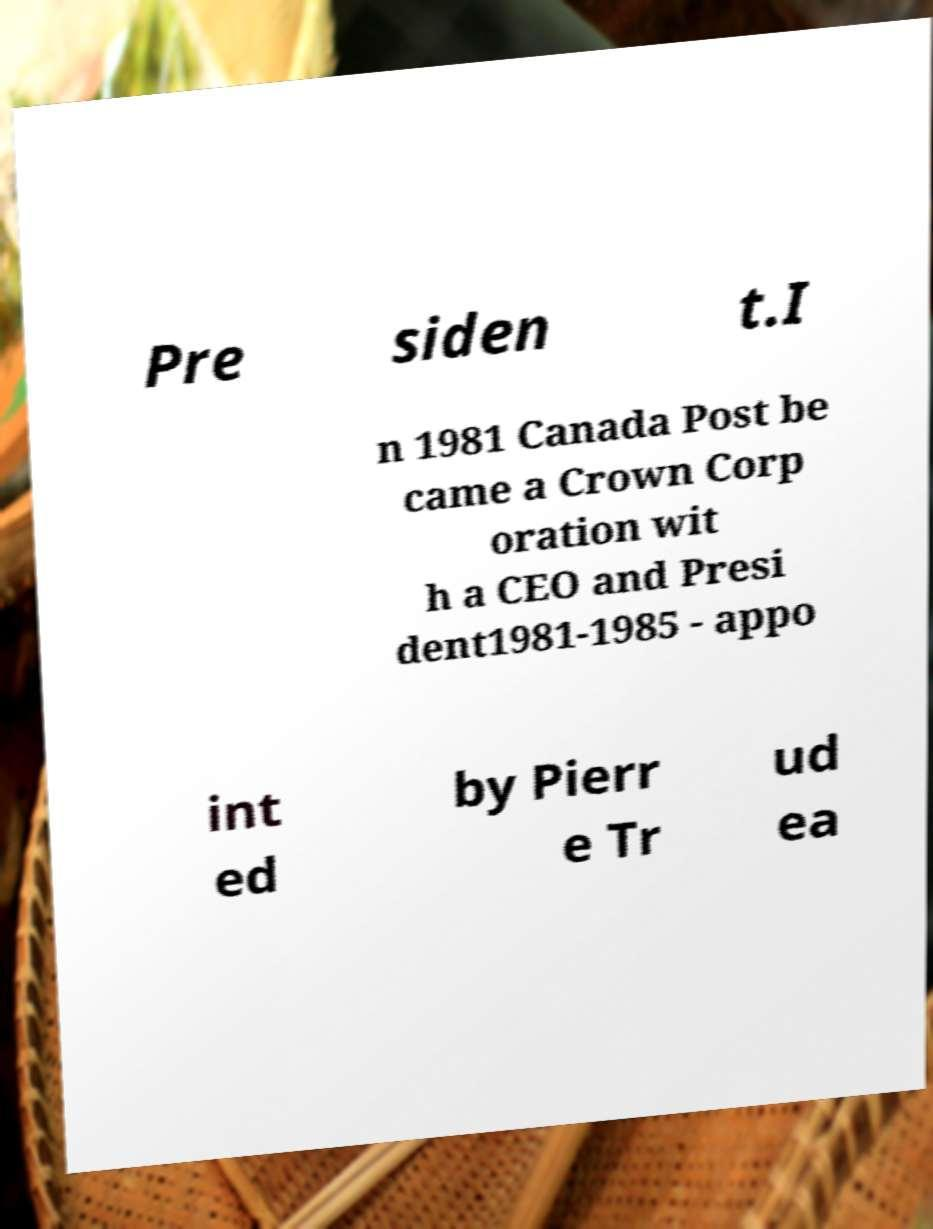There's text embedded in this image that I need extracted. Can you transcribe it verbatim? Pre siden t.I n 1981 Canada Post be came a Crown Corp oration wit h a CEO and Presi dent1981-1985 - appo int ed by Pierr e Tr ud ea 